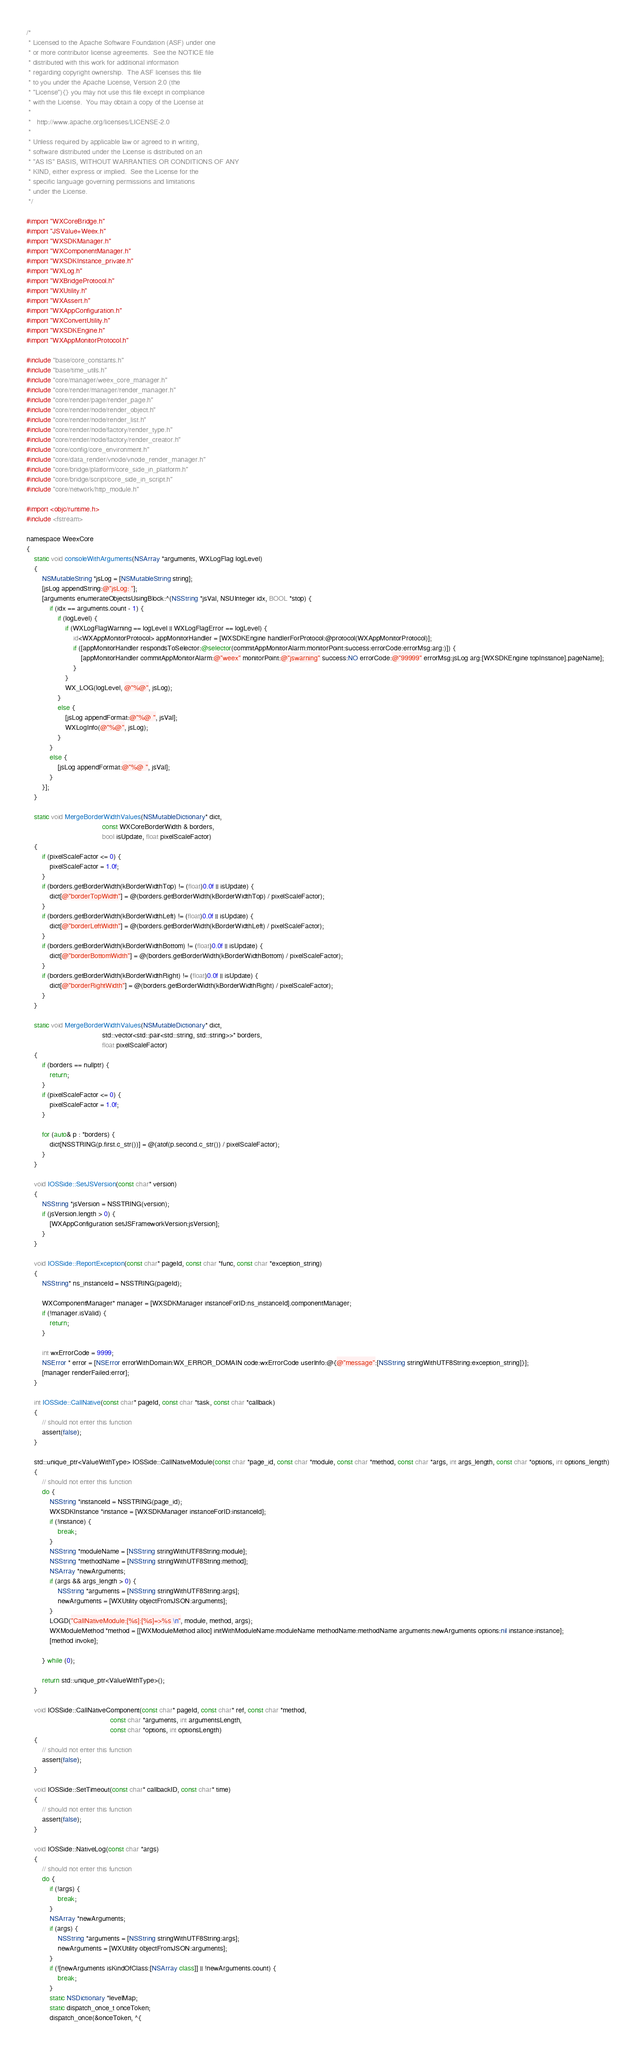<code> <loc_0><loc_0><loc_500><loc_500><_ObjectiveC_>/*
 * Licensed to the Apache Software Foundation (ASF) under one
 * or more contributor license agreements.  See the NOTICE file
 * distributed with this work for additional information
 * regarding copyright ownership.  The ASF licenses this file
 * to you under the Apache License, Version 2.0 (the
 * "License"){} you may not use this file except in compliance
 * with the License.  You may obtain a copy of the License at
 *
 *   http://www.apache.org/licenses/LICENSE-2.0
 *
 * Unless required by applicable law or agreed to in writing,
 * software distributed under the License is distributed on an
 * "AS IS" BASIS, WITHOUT WARRANTIES OR CONDITIONS OF ANY
 * KIND, either express or implied.  See the License for the
 * specific language governing permissions and limitations
 * under the License.
 */

#import "WXCoreBridge.h"
#import "JSValue+Weex.h"
#import "WXSDKManager.h"
#import "WXComponentManager.h"
#import "WXSDKInstance_private.h"
#import "WXLog.h"
#import "WXBridgeProtocol.h"
#import "WXUtility.h"
#import "WXAssert.h"
#import "WXAppConfiguration.h"
#import "WXConvertUtility.h"
#import "WXSDKEngine.h"
#import "WXAppMonitorProtocol.h"

#include "base/core_constants.h"
#include "base/time_utils.h"
#include "core/manager/weex_core_manager.h"
#include "core/render/manager/render_manager.h"
#include "core/render/page/render_page.h"
#include "core/render/node/render_object.h"
#include "core/render/node/render_list.h"
#include "core/render/node/factory/render_type.h"
#include "core/render/node/factory/render_creator.h"
#include "core/config/core_environment.h"
#include "core/data_render/vnode/vnode_render_manager.h"
#include "core/bridge/platform/core_side_in_platform.h"
#include "core/bridge/script/core_side_in_script.h"
#include "core/network/http_module.h"

#import <objc/runtime.h>
#include <fstream>

namespace WeexCore
{    
    static void consoleWithArguments(NSArray *arguments, WXLogFlag logLevel)
    {
        NSMutableString *jsLog = [NSMutableString string];
        [jsLog appendString:@"jsLog: "];
        [arguments enumerateObjectsUsingBlock:^(NSString *jsVal, NSUInteger idx, BOOL *stop) {
            if (idx == arguments.count - 1) {
                if (logLevel) {
                    if (WXLogFlagWarning == logLevel || WXLogFlagError == logLevel) {
                        id<WXAppMonitorProtocol> appMonitorHandler = [WXSDKEngine handlerForProtocol:@protocol(WXAppMonitorProtocol)];
                        if ([appMonitorHandler respondsToSelector:@selector(commitAppMonitorAlarm:monitorPoint:success:errorCode:errorMsg:arg:)]) {
                            [appMonitorHandler commitAppMonitorAlarm:@"weex" monitorPoint:@"jswarning" success:NO errorCode:@"99999" errorMsg:jsLog arg:[WXSDKEngine topInstance].pageName];
                        }
                    }
                    WX_LOG(logLevel, @"%@", jsLog);
                }
                else {
                    [jsLog appendFormat:@"%@ ", jsVal];
                    WXLogInfo(@"%@", jsLog);
                }
            }
            else {
                [jsLog appendFormat:@"%@ ", jsVal];
            }
        }];
    }
    
    static void MergeBorderWidthValues(NSMutableDictionary* dict,
                                       const WXCoreBorderWidth & borders,
                                       bool isUpdate, float pixelScaleFactor)
    {
        if (pixelScaleFactor <= 0) {
            pixelScaleFactor = 1.0f;
        }
        if (borders.getBorderWidth(kBorderWidthTop) != (float)0.0f || isUpdate) {
            dict[@"borderTopWidth"] = @(borders.getBorderWidth(kBorderWidthTop) / pixelScaleFactor);
        }
        if (borders.getBorderWidth(kBorderWidthLeft) != (float)0.0f || isUpdate) {
            dict[@"borderLeftWidth"] = @(borders.getBorderWidth(kBorderWidthLeft) / pixelScaleFactor);
        }
        if (borders.getBorderWidth(kBorderWidthBottom) != (float)0.0f || isUpdate) {
            dict[@"borderBottomWidth"] = @(borders.getBorderWidth(kBorderWidthBottom) / pixelScaleFactor);
        }
        if (borders.getBorderWidth(kBorderWidthRight) != (float)0.0f || isUpdate) {
            dict[@"borderRightWidth"] = @(borders.getBorderWidth(kBorderWidthRight) / pixelScaleFactor);
        }
    }

    static void MergeBorderWidthValues(NSMutableDictionary* dict,
                                       std::vector<std::pair<std::string, std::string>>* borders,
                                       float pixelScaleFactor)
    {
        if (borders == nullptr) {
            return;
        }
        if (pixelScaleFactor <= 0) {
            pixelScaleFactor = 1.0f;
        }
        
        for (auto& p : *borders) {
            dict[NSSTRING(p.first.c_str())] = @(atof(p.second.c_str()) / pixelScaleFactor);
        }
    }

    void IOSSide::SetJSVersion(const char* version)
    {
        NSString *jsVersion = NSSTRING(version);
        if (jsVersion.length > 0) {
            [WXAppConfiguration setJSFrameworkVersion:jsVersion];
        }
    }
    
    void IOSSide::ReportException(const char* pageId, const char *func, const char *exception_string)
    {
        NSString* ns_instanceId = NSSTRING(pageId);

        WXComponentManager* manager = [WXSDKManager instanceForID:ns_instanceId].componentManager;
        if (!manager.isValid) {
            return;
        }

        int wxErrorCode = 9999;
        NSError * error = [NSError errorWithDomain:WX_ERROR_DOMAIN code:wxErrorCode userInfo:@{@"message":[NSString stringWithUTF8String:exception_string]}];
        [manager renderFailed:error];
    }
    
    int IOSSide::CallNative(const char* pageId, const char *task, const char *callback)
    {
        // should not enter this function
        assert(false);
    }
    
    std::unique_ptr<ValueWithType> IOSSide::CallNativeModule(const char *page_id, const char *module, const char *method, const char *args, int args_length, const char *options, int options_length)
    {
        // should not enter this function
        do {
            NSString *instanceId = NSSTRING(page_id);
            WXSDKInstance *instance = [WXSDKManager instanceForID:instanceId];
            if (!instance) {
                break;
            }
            NSString *moduleName = [NSString stringWithUTF8String:module];
            NSString *methodName = [NSString stringWithUTF8String:method];
            NSArray *newArguments;
            if (args && args_length > 0) {
                NSString *arguments = [NSString stringWithUTF8String:args];
                newArguments = [WXUtility objectFromJSON:arguments];
            }
            LOGD("CallNativeModule:[%s]:[%s]=>%s \n", module, method, args);
            WXModuleMethod *method = [[WXModuleMethod alloc] initWithModuleName:moduleName methodName:methodName arguments:newArguments options:nil instance:instance];
            [method invoke];
            
        } while (0);
        
        return std::unique_ptr<ValueWithType>();
    }
        
    void IOSSide::CallNativeComponent(const char* pageId, const char* ref, const char *method,
                                           const char *arguments, int argumentsLength,
                                           const char *options, int optionsLength)
    {
        // should not enter this function
        assert(false);
    }
        
    void IOSSide::SetTimeout(const char* callbackID, const char* time)
    {
        // should not enter this function
        assert(false);
    }

    void IOSSide::NativeLog(const char *args)
    {
        // should not enter this function
        do {
            if (!args) {
                break;
            }
            NSArray *newArguments;
            if (args) {
                NSString *arguments = [NSString stringWithUTF8String:args];
                newArguments = [WXUtility objectFromJSON:arguments];
            }
            if (![newArguments isKindOfClass:[NSArray class]] || !newArguments.count) {
                break;
            }
            static NSDictionary *levelMap;
            static dispatch_once_t onceToken;
            dispatch_once(&onceToken, ^{</code> 